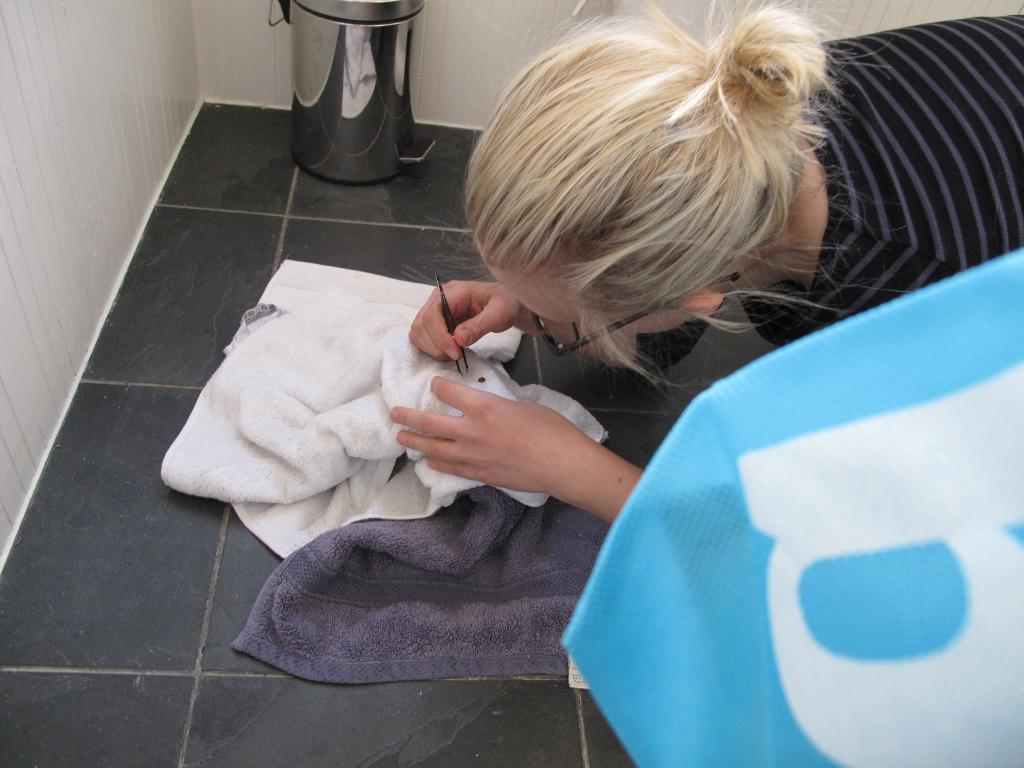<image>
Describe the image concisely. A woman works over a towel while some blue fabric has a white letter b on it. 